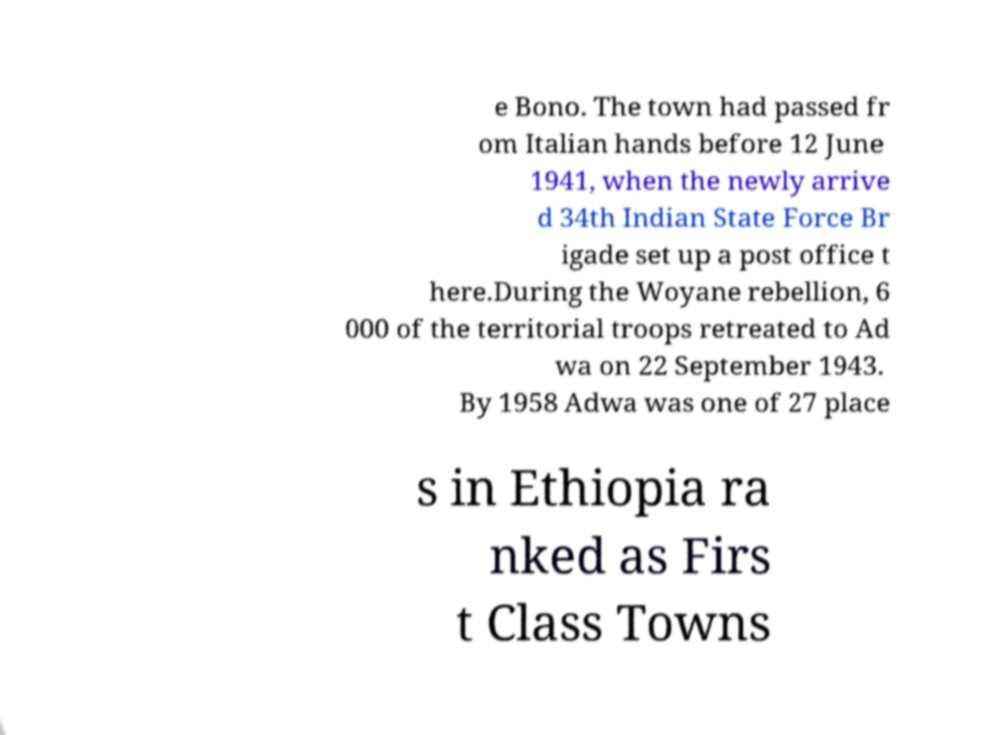Please identify and transcribe the text found in this image. e Bono. The town had passed fr om Italian hands before 12 June 1941, when the newly arrive d 34th Indian State Force Br igade set up a post office t here.During the Woyane rebellion, 6 000 of the territorial troops retreated to Ad wa on 22 September 1943. By 1958 Adwa was one of 27 place s in Ethiopia ra nked as Firs t Class Towns 